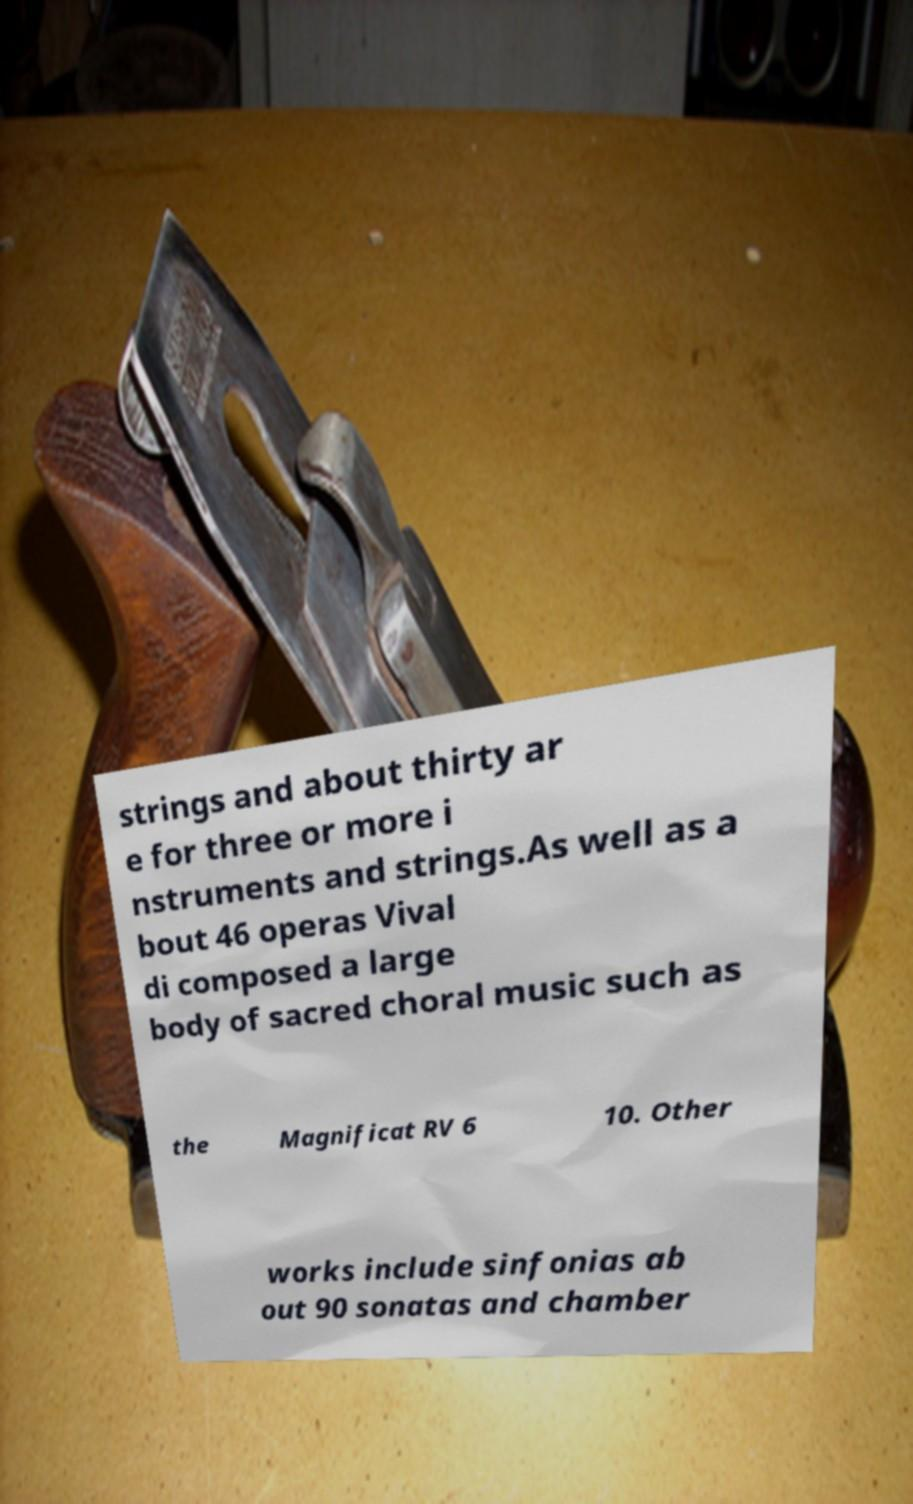Please identify and transcribe the text found in this image. strings and about thirty ar e for three or more i nstruments and strings.As well as a bout 46 operas Vival di composed a large body of sacred choral music such as the Magnificat RV 6 10. Other works include sinfonias ab out 90 sonatas and chamber 